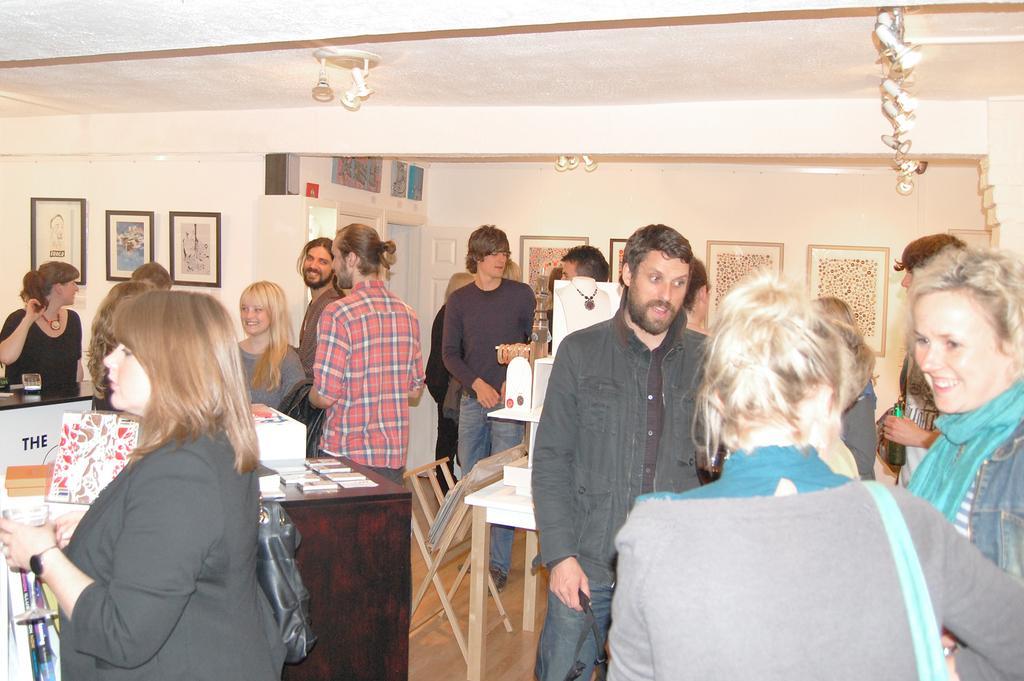Please provide a concise description of this image. In this picture we can see some persons are standing on the floor. There is a table. On the background there is a wall and these are the frames. And this is floor. 